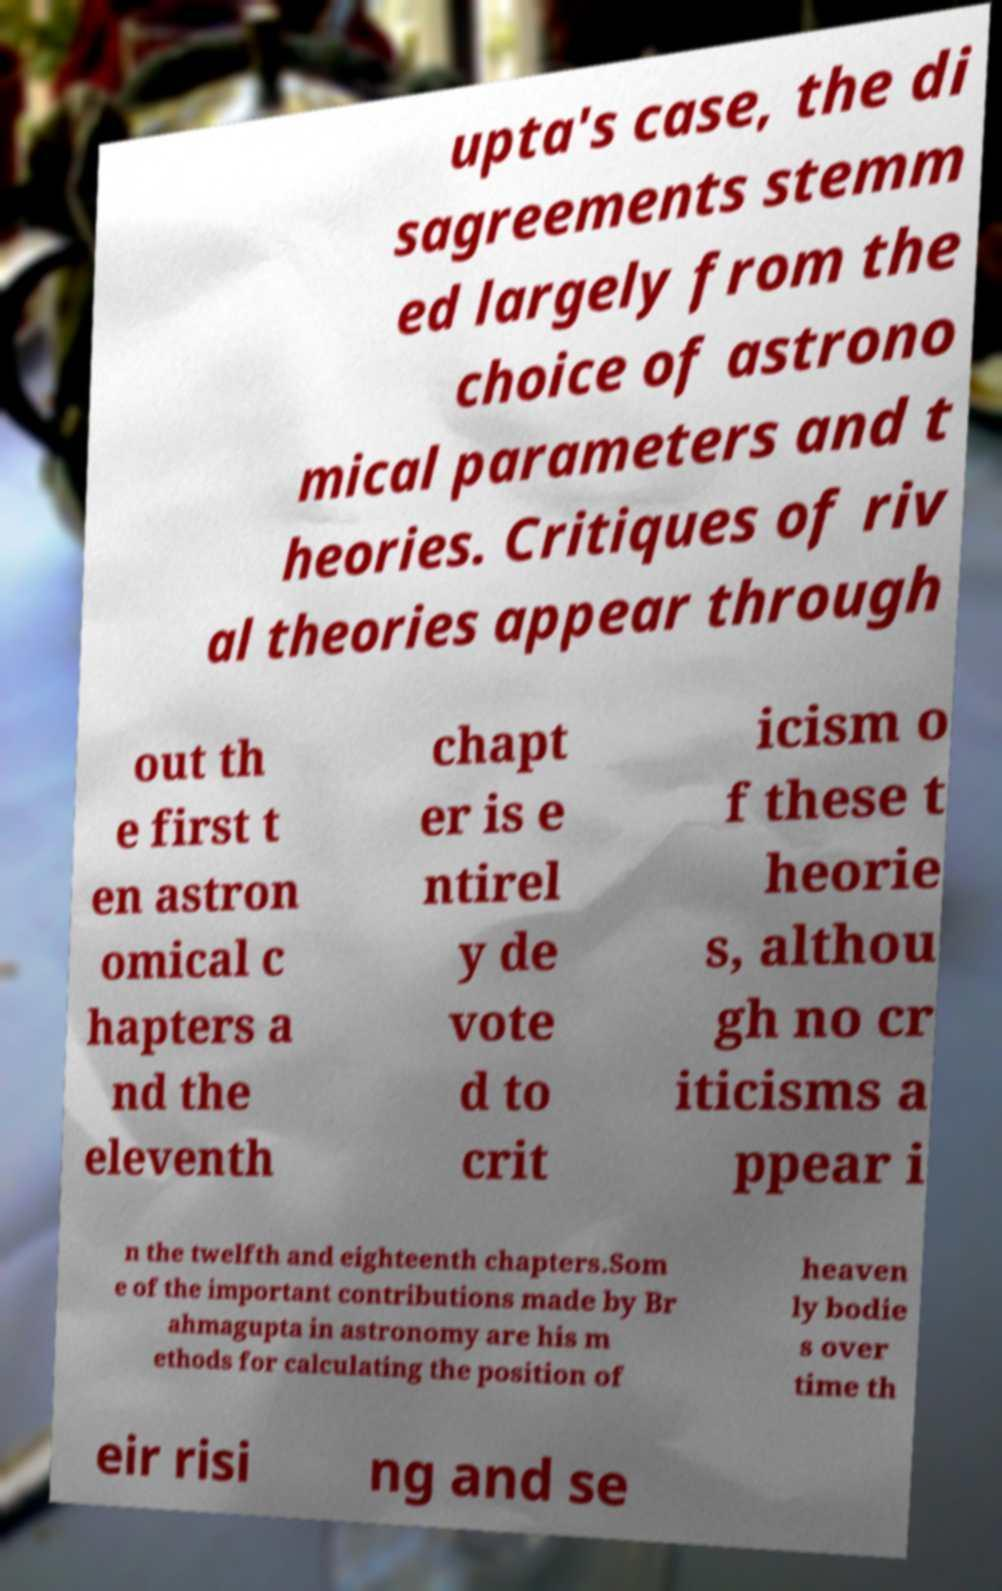Please read and relay the text visible in this image. What does it say? upta's case, the di sagreements stemm ed largely from the choice of astrono mical parameters and t heories. Critiques of riv al theories appear through out th e first t en astron omical c hapters a nd the eleventh chapt er is e ntirel y de vote d to crit icism o f these t heorie s, althou gh no cr iticisms a ppear i n the twelfth and eighteenth chapters.Som e of the important contributions made by Br ahmagupta in astronomy are his m ethods for calculating the position of heaven ly bodie s over time th eir risi ng and se 